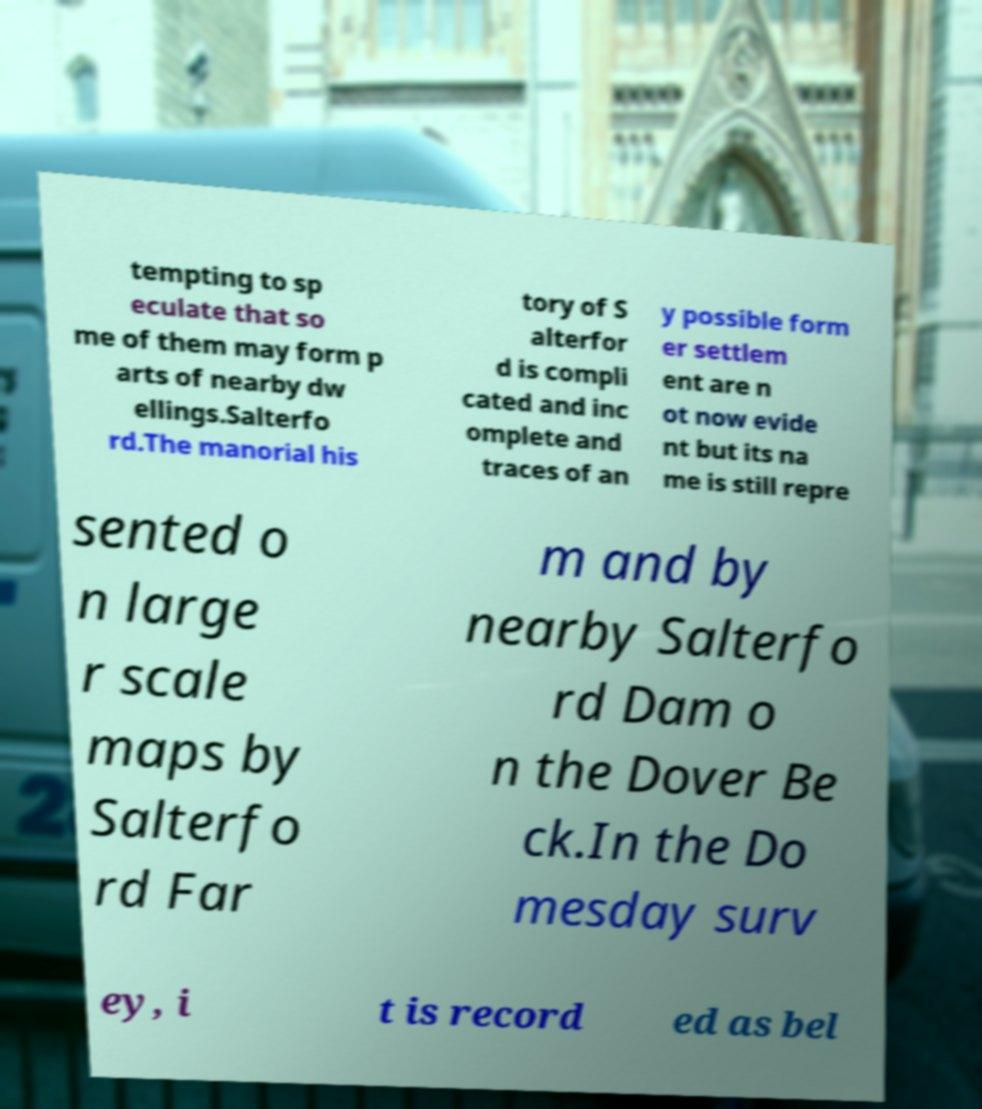Can you read and provide the text displayed in the image?This photo seems to have some interesting text. Can you extract and type it out for me? tempting to sp eculate that so me of them may form p arts of nearby dw ellings.Salterfo rd.The manorial his tory of S alterfor d is compli cated and inc omplete and traces of an y possible form er settlem ent are n ot now evide nt but its na me is still repre sented o n large r scale maps by Salterfo rd Far m and by nearby Salterfo rd Dam o n the Dover Be ck.In the Do mesday surv ey, i t is record ed as bel 